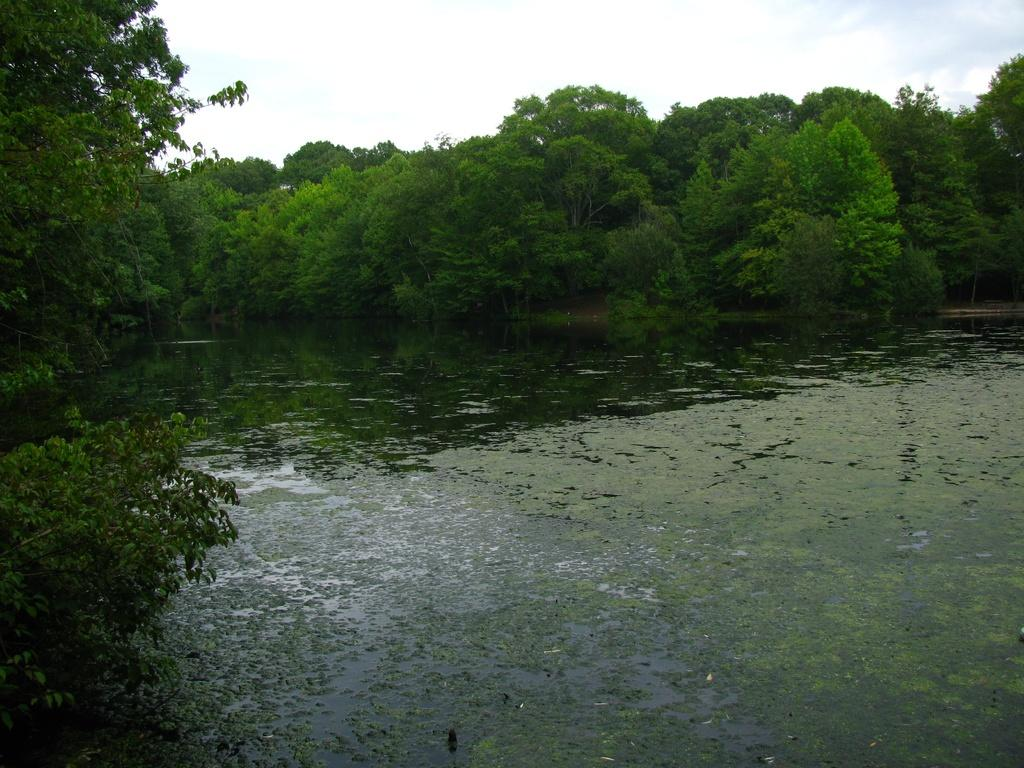What type of vegetation can be seen in the image? There are trees in the image. What natural element is visible in the image besides the trees? There is water visible in the image. What can be seen in the background of the image? The sky is visible in the background of the image. What type of print can be seen on the edge of the water in the image? There is no print visible on the edge of the water in the image. 